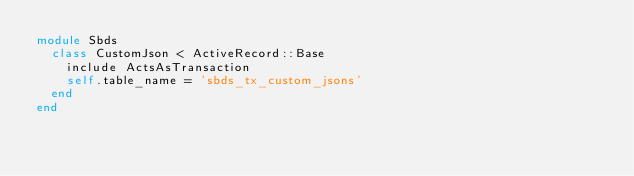<code> <loc_0><loc_0><loc_500><loc_500><_Ruby_>module Sbds
  class CustomJson < ActiveRecord::Base
    include ActsAsTransaction
    self.table_name = 'sbds_tx_custom_jsons'
  end
end
</code> 